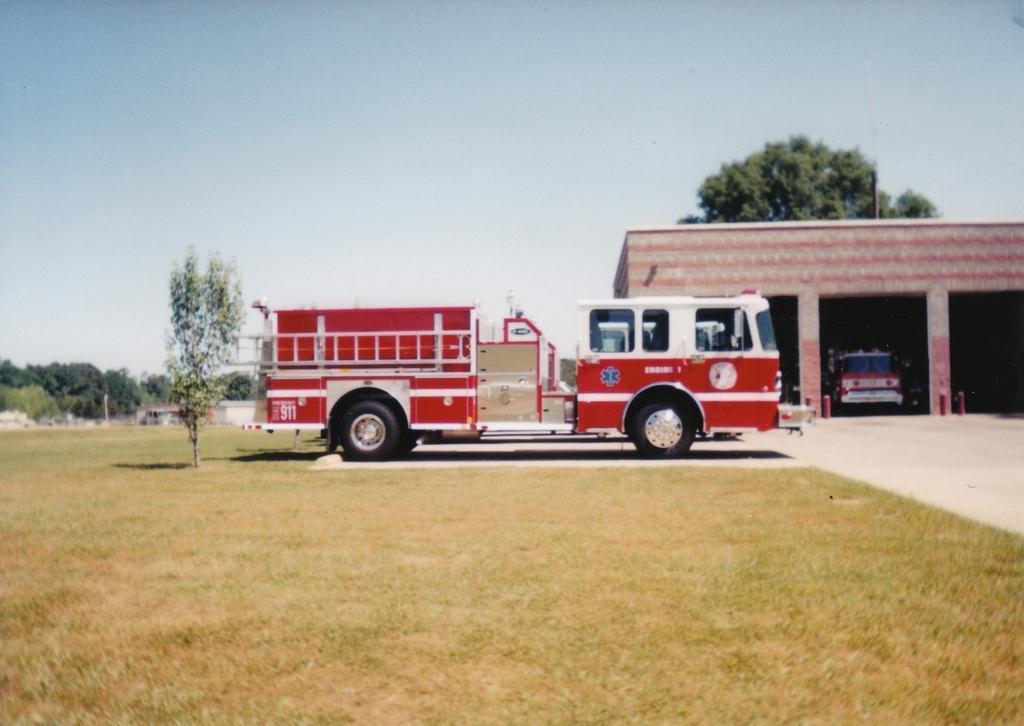How would you summarize this image in a sentence or two? In this image there is the sky towards the top of the image, there are trees, there is a wall towards the right of the image, there are pillars, there are vehicles on the ground, there is grass towards the bottom of the image. 